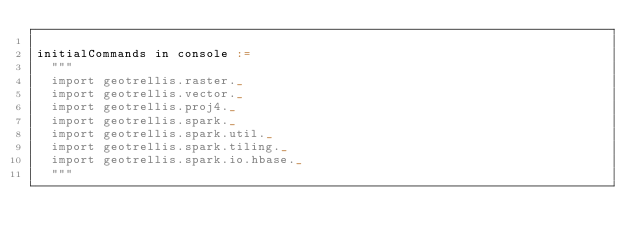<code> <loc_0><loc_0><loc_500><loc_500><_Scala_>
initialCommands in console :=
  """
  import geotrellis.raster._
  import geotrellis.vector._
  import geotrellis.proj4._
  import geotrellis.spark._
  import geotrellis.spark.util._
  import geotrellis.spark.tiling._
  import geotrellis.spark.io.hbase._
  """
</code> 